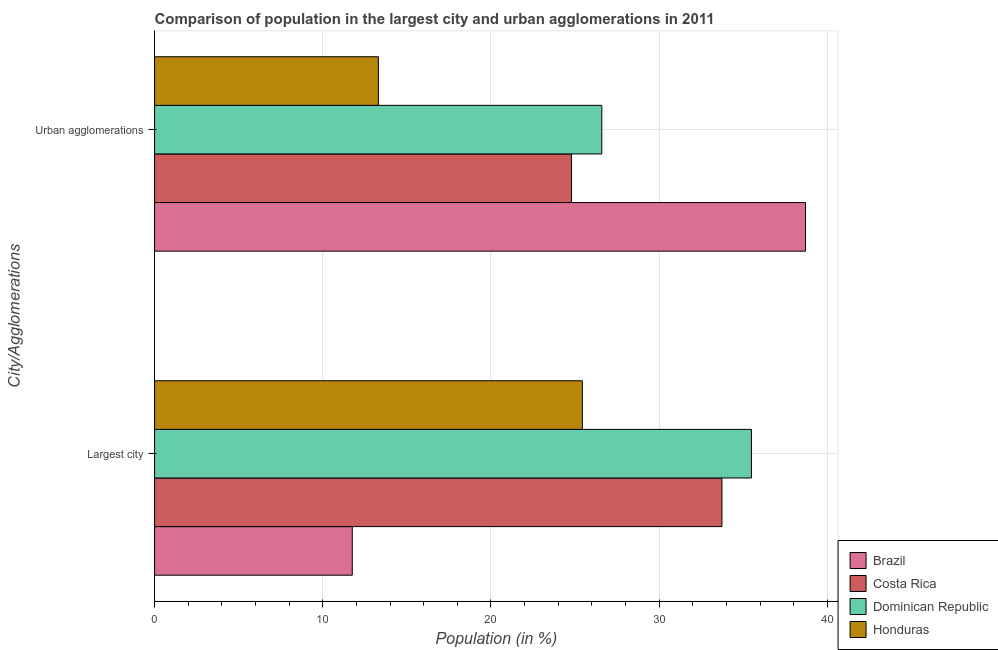How many different coloured bars are there?
Make the answer very short. 4. Are the number of bars per tick equal to the number of legend labels?
Make the answer very short. Yes. Are the number of bars on each tick of the Y-axis equal?
Your answer should be compact. Yes. How many bars are there on the 1st tick from the top?
Provide a succinct answer. 4. What is the label of the 1st group of bars from the top?
Keep it short and to the point. Urban agglomerations. What is the population in the largest city in Honduras?
Ensure brevity in your answer.  25.44. Across all countries, what is the maximum population in the largest city?
Your response must be concise. 35.49. Across all countries, what is the minimum population in urban agglomerations?
Offer a very short reply. 13.31. In which country was the population in the largest city maximum?
Offer a terse response. Dominican Republic. In which country was the population in urban agglomerations minimum?
Provide a succinct answer. Honduras. What is the total population in the largest city in the graph?
Your response must be concise. 106.42. What is the difference between the population in urban agglomerations in Honduras and that in Brazil?
Your response must be concise. -25.4. What is the difference between the population in the largest city in Costa Rica and the population in urban agglomerations in Honduras?
Offer a terse response. 20.43. What is the average population in urban agglomerations per country?
Offer a terse response. 25.85. What is the difference between the population in urban agglomerations and population in the largest city in Brazil?
Your response must be concise. 26.95. What is the ratio of the population in the largest city in Honduras to that in Dominican Republic?
Offer a very short reply. 0.72. What does the 2nd bar from the top in Largest city represents?
Offer a very short reply. Dominican Republic. What does the 2nd bar from the bottom in Largest city represents?
Your answer should be compact. Costa Rica. How many bars are there?
Your answer should be compact. 8. How many countries are there in the graph?
Your response must be concise. 4. What is the difference between two consecutive major ticks on the X-axis?
Make the answer very short. 10. Are the values on the major ticks of X-axis written in scientific E-notation?
Offer a very short reply. No. Does the graph contain grids?
Offer a very short reply. Yes. Where does the legend appear in the graph?
Provide a succinct answer. Bottom right. How many legend labels are there?
Provide a succinct answer. 4. How are the legend labels stacked?
Provide a short and direct response. Vertical. What is the title of the graph?
Give a very brief answer. Comparison of population in the largest city and urban agglomerations in 2011. Does "Togo" appear as one of the legend labels in the graph?
Offer a terse response. No. What is the label or title of the X-axis?
Provide a short and direct response. Population (in %). What is the label or title of the Y-axis?
Your response must be concise. City/Agglomerations. What is the Population (in %) of Brazil in Largest city?
Keep it short and to the point. 11.75. What is the Population (in %) of Costa Rica in Largest city?
Keep it short and to the point. 33.74. What is the Population (in %) in Dominican Republic in Largest city?
Ensure brevity in your answer.  35.49. What is the Population (in %) of Honduras in Largest city?
Provide a short and direct response. 25.44. What is the Population (in %) in Brazil in Urban agglomerations?
Offer a terse response. 38.71. What is the Population (in %) in Costa Rica in Urban agglomerations?
Keep it short and to the point. 24.79. What is the Population (in %) of Dominican Republic in Urban agglomerations?
Give a very brief answer. 26.59. What is the Population (in %) in Honduras in Urban agglomerations?
Offer a terse response. 13.31. Across all City/Agglomerations, what is the maximum Population (in %) of Brazil?
Give a very brief answer. 38.71. Across all City/Agglomerations, what is the maximum Population (in %) of Costa Rica?
Provide a succinct answer. 33.74. Across all City/Agglomerations, what is the maximum Population (in %) in Dominican Republic?
Keep it short and to the point. 35.49. Across all City/Agglomerations, what is the maximum Population (in %) of Honduras?
Provide a short and direct response. 25.44. Across all City/Agglomerations, what is the minimum Population (in %) of Brazil?
Your answer should be compact. 11.75. Across all City/Agglomerations, what is the minimum Population (in %) in Costa Rica?
Give a very brief answer. 24.79. Across all City/Agglomerations, what is the minimum Population (in %) in Dominican Republic?
Give a very brief answer. 26.59. Across all City/Agglomerations, what is the minimum Population (in %) in Honduras?
Your response must be concise. 13.31. What is the total Population (in %) of Brazil in the graph?
Your response must be concise. 50.46. What is the total Population (in %) of Costa Rica in the graph?
Provide a succinct answer. 58.52. What is the total Population (in %) in Dominican Republic in the graph?
Your answer should be very brief. 62.08. What is the total Population (in %) of Honduras in the graph?
Provide a succinct answer. 38.74. What is the difference between the Population (in %) in Brazil in Largest city and that in Urban agglomerations?
Your response must be concise. -26.95. What is the difference between the Population (in %) of Costa Rica in Largest city and that in Urban agglomerations?
Make the answer very short. 8.95. What is the difference between the Population (in %) in Dominican Republic in Largest city and that in Urban agglomerations?
Ensure brevity in your answer.  8.9. What is the difference between the Population (in %) of Honduras in Largest city and that in Urban agglomerations?
Your response must be concise. 12.13. What is the difference between the Population (in %) in Brazil in Largest city and the Population (in %) in Costa Rica in Urban agglomerations?
Your answer should be compact. -13.03. What is the difference between the Population (in %) in Brazil in Largest city and the Population (in %) in Dominican Republic in Urban agglomerations?
Give a very brief answer. -14.84. What is the difference between the Population (in %) in Brazil in Largest city and the Population (in %) in Honduras in Urban agglomerations?
Keep it short and to the point. -1.55. What is the difference between the Population (in %) in Costa Rica in Largest city and the Population (in %) in Dominican Republic in Urban agglomerations?
Your answer should be compact. 7.14. What is the difference between the Population (in %) of Costa Rica in Largest city and the Population (in %) of Honduras in Urban agglomerations?
Ensure brevity in your answer.  20.43. What is the difference between the Population (in %) of Dominican Republic in Largest city and the Population (in %) of Honduras in Urban agglomerations?
Make the answer very short. 22.18. What is the average Population (in %) in Brazil per City/Agglomerations?
Your response must be concise. 25.23. What is the average Population (in %) in Costa Rica per City/Agglomerations?
Make the answer very short. 29.26. What is the average Population (in %) of Dominican Republic per City/Agglomerations?
Give a very brief answer. 31.04. What is the average Population (in %) of Honduras per City/Agglomerations?
Offer a terse response. 19.37. What is the difference between the Population (in %) in Brazil and Population (in %) in Costa Rica in Largest city?
Offer a very short reply. -21.98. What is the difference between the Population (in %) in Brazil and Population (in %) in Dominican Republic in Largest city?
Keep it short and to the point. -23.74. What is the difference between the Population (in %) of Brazil and Population (in %) of Honduras in Largest city?
Offer a terse response. -13.68. What is the difference between the Population (in %) of Costa Rica and Population (in %) of Dominican Republic in Largest city?
Provide a succinct answer. -1.75. What is the difference between the Population (in %) of Costa Rica and Population (in %) of Honduras in Largest city?
Your response must be concise. 8.3. What is the difference between the Population (in %) of Dominican Republic and Population (in %) of Honduras in Largest city?
Provide a short and direct response. 10.05. What is the difference between the Population (in %) in Brazil and Population (in %) in Costa Rica in Urban agglomerations?
Keep it short and to the point. 13.92. What is the difference between the Population (in %) in Brazil and Population (in %) in Dominican Republic in Urban agglomerations?
Ensure brevity in your answer.  12.11. What is the difference between the Population (in %) of Brazil and Population (in %) of Honduras in Urban agglomerations?
Your answer should be very brief. 25.4. What is the difference between the Population (in %) in Costa Rica and Population (in %) in Dominican Republic in Urban agglomerations?
Ensure brevity in your answer.  -1.81. What is the difference between the Population (in %) of Costa Rica and Population (in %) of Honduras in Urban agglomerations?
Offer a very short reply. 11.48. What is the difference between the Population (in %) in Dominican Republic and Population (in %) in Honduras in Urban agglomerations?
Provide a short and direct response. 13.29. What is the ratio of the Population (in %) in Brazil in Largest city to that in Urban agglomerations?
Provide a short and direct response. 0.3. What is the ratio of the Population (in %) in Costa Rica in Largest city to that in Urban agglomerations?
Provide a short and direct response. 1.36. What is the ratio of the Population (in %) in Dominican Republic in Largest city to that in Urban agglomerations?
Make the answer very short. 1.33. What is the ratio of the Population (in %) of Honduras in Largest city to that in Urban agglomerations?
Provide a short and direct response. 1.91. What is the difference between the highest and the second highest Population (in %) of Brazil?
Offer a very short reply. 26.95. What is the difference between the highest and the second highest Population (in %) in Costa Rica?
Provide a succinct answer. 8.95. What is the difference between the highest and the second highest Population (in %) in Dominican Republic?
Your response must be concise. 8.9. What is the difference between the highest and the second highest Population (in %) of Honduras?
Make the answer very short. 12.13. What is the difference between the highest and the lowest Population (in %) of Brazil?
Offer a very short reply. 26.95. What is the difference between the highest and the lowest Population (in %) of Costa Rica?
Ensure brevity in your answer.  8.95. What is the difference between the highest and the lowest Population (in %) in Dominican Republic?
Give a very brief answer. 8.9. What is the difference between the highest and the lowest Population (in %) of Honduras?
Your answer should be very brief. 12.13. 